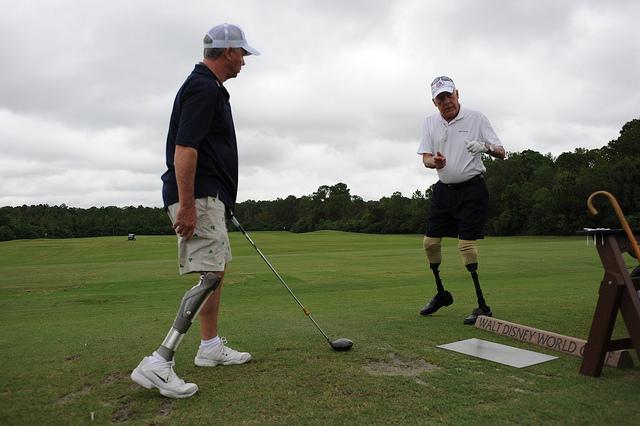Is anyone wearing a hat?
Keep it brief. Yes. What sport are they playing?
Concise answer only. Golf. Are these men wearing artificial limbs?
Answer briefly. Yes. 